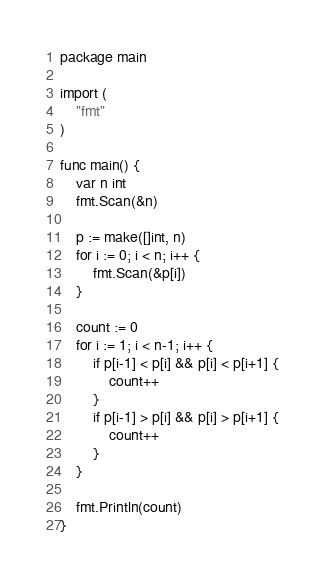Convert code to text. <code><loc_0><loc_0><loc_500><loc_500><_Go_>package main

import (
	"fmt"
)

func main() {
	var n int
	fmt.Scan(&n)

	p := make([]int, n)
	for i := 0; i < n; i++ {
		fmt.Scan(&p[i])
	}

	count := 0
	for i := 1; i < n-1; i++ {
		if p[i-1] < p[i] && p[i] < p[i+1] {
			count++
		}
		if p[i-1] > p[i] && p[i] > p[i+1] {
			count++
		}
	}

	fmt.Println(count)
}
</code> 